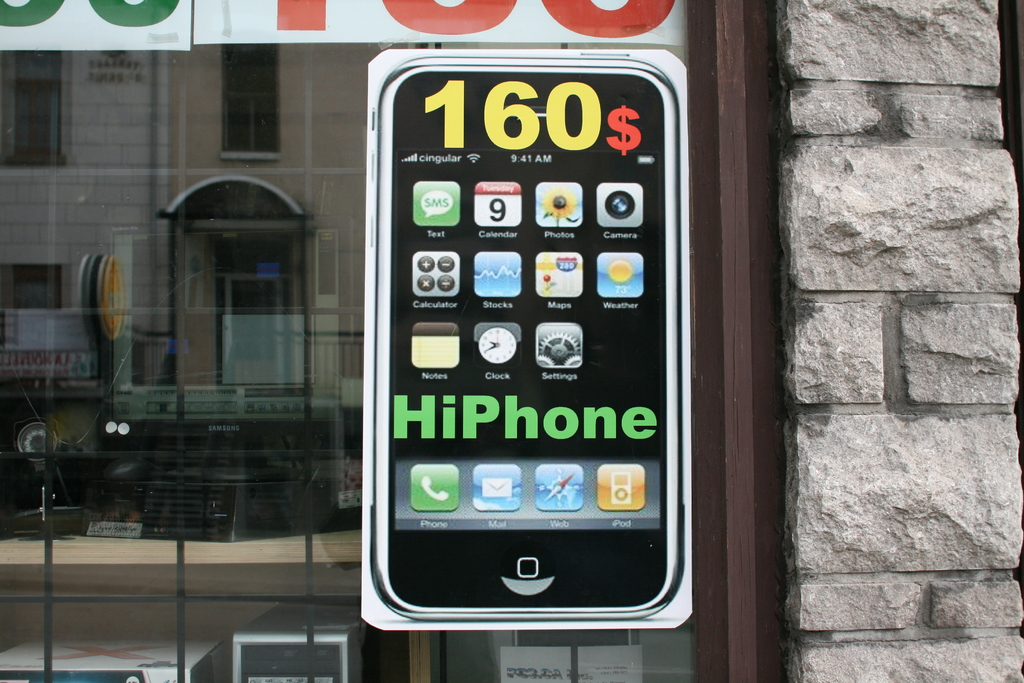Is there any specific branding visible on the advertisement, and what does it suggest about the market strategy? The advertisement brands the device as the 'HiPhone' and uses Cingular as the network provider, suggesting a playful approach to marketing that leverages familiar elements from popular products to attract a broad consumer base seeking affordable alternatives. 